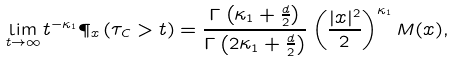<formula> <loc_0><loc_0><loc_500><loc_500>\lim _ { t \to \infty } t ^ { - \kappa _ { 1 } } \P _ { x } \left ( \tau _ { C } > t \right ) = \frac { \Gamma \left ( \kappa _ { 1 } + \frac { d } { 2 } \right ) } { \Gamma \left ( 2 \kappa _ { 1 } + \frac { d } { 2 } \right ) } \left ( \frac { | x | ^ { 2 } } { 2 } \right ) ^ { \kappa _ { 1 } } M ( x ) ,</formula> 